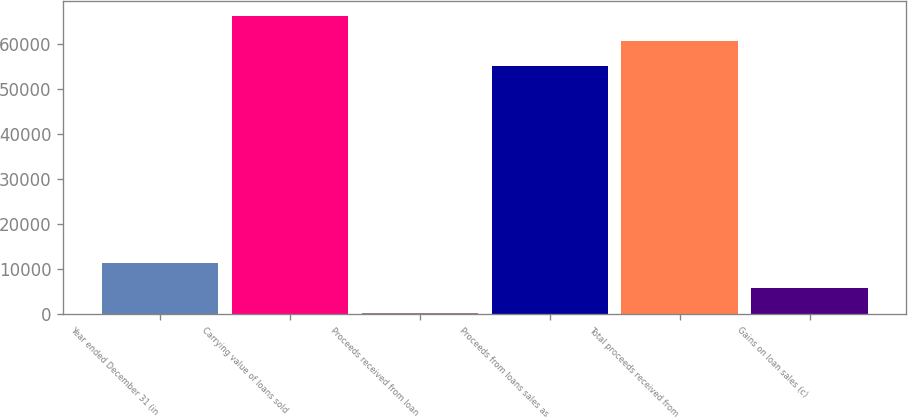Convert chart to OTSL. <chart><loc_0><loc_0><loc_500><loc_500><bar_chart><fcel>Year ended December 31 (in<fcel>Carrying value of loans sold<fcel>Proceeds received from loan<fcel>Proceeds from loans sales as<fcel>Total proceeds received from<fcel>Gains on loan sales (c)<nl><fcel>11368.4<fcel>66225.4<fcel>260<fcel>55117<fcel>60671.2<fcel>5814.2<nl></chart> 